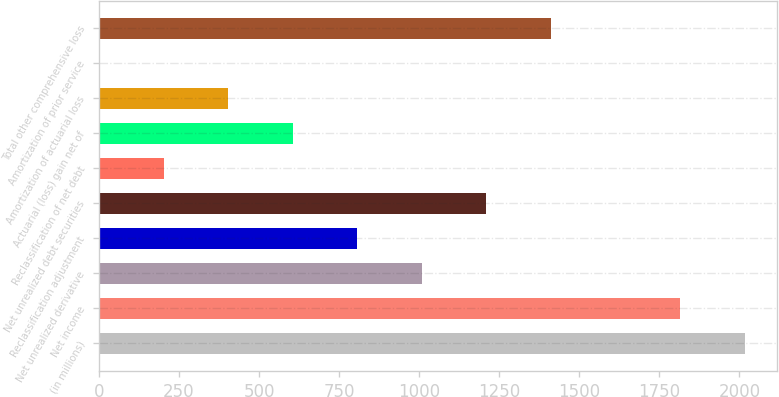Convert chart. <chart><loc_0><loc_0><loc_500><loc_500><bar_chart><fcel>(in millions)<fcel>Net income<fcel>Net unrealized derivative<fcel>Reclassification adjustment<fcel>Net unrealized debt securities<fcel>Reclassification of net debt<fcel>Actuarial (loss) gain net of<fcel>Amortization of actuarial loss<fcel>Amortization of prior service<fcel>Total other comprehensive loss<nl><fcel>2016<fcel>1814.5<fcel>1008.5<fcel>807<fcel>1210<fcel>202.5<fcel>605.5<fcel>404<fcel>1<fcel>1411.5<nl></chart> 